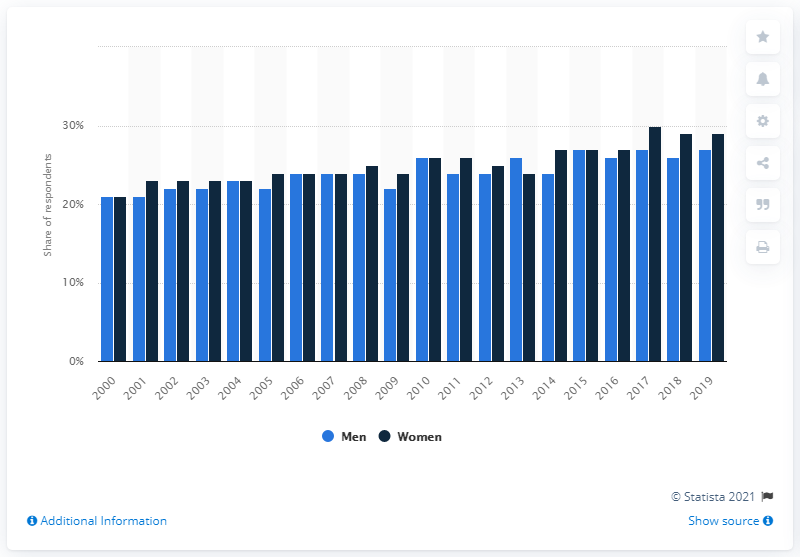Indicate a few pertinent items in this graphic. In 2019, approximately 27% of men in England were obese. In 2019, it was reported that 29% of women in England were obese. Obesity began to rise in England in the year 2000. 